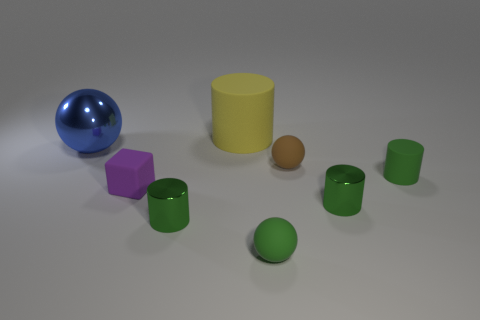What is the color of the tiny rubber object that is the same shape as the big matte object?
Keep it short and to the point. Green. What number of objects are either tiny green balls or tiny green objects in front of the purple object?
Make the answer very short. 3. Are there fewer small brown objects that are to the left of the block than big spheres?
Offer a very short reply. Yes. What is the size of the rubber cylinder right of the green shiny cylinder to the right of the ball that is in front of the tiny purple block?
Your answer should be compact. Small. What is the color of the cylinder that is in front of the blue shiny thing and behind the purple matte block?
Give a very brief answer. Green. What number of large things are there?
Ensure brevity in your answer.  2. Is there anything else that has the same size as the shiny ball?
Your response must be concise. Yes. Is the tiny purple cube made of the same material as the blue object?
Your answer should be compact. No. Does the green metal object on the left side of the yellow matte cylinder have the same size as the ball to the left of the purple thing?
Provide a short and direct response. No. Are there fewer small purple objects than big gray rubber objects?
Offer a very short reply. No. 